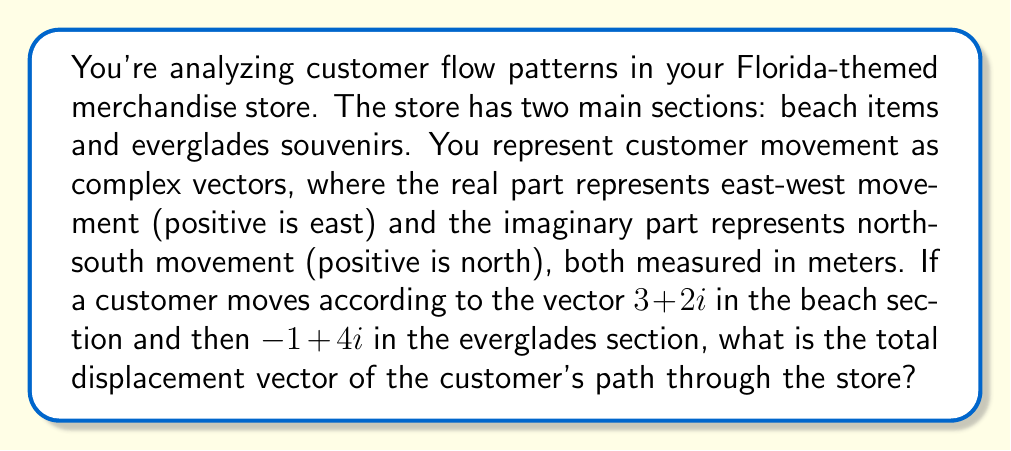Show me your answer to this math problem. To solve this problem, we need to add the two complex vectors representing the customer's movement:

1) First vector (beach section): $v_1 = 3+2i$
2) Second vector (everglades section): $v_2 = -1+4i$

To add complex numbers, we add the real and imaginary parts separately:

$$ v_{total} = v_1 + v_2 = (3+2i) + (-1+4i) $$

$$ = (3-1) + (2+4)i $$

$$ = 2 + 6i $$

This result means the customer's total displacement is 2 meters east and 6 meters north from their starting point.
Answer: $2+6i$ 